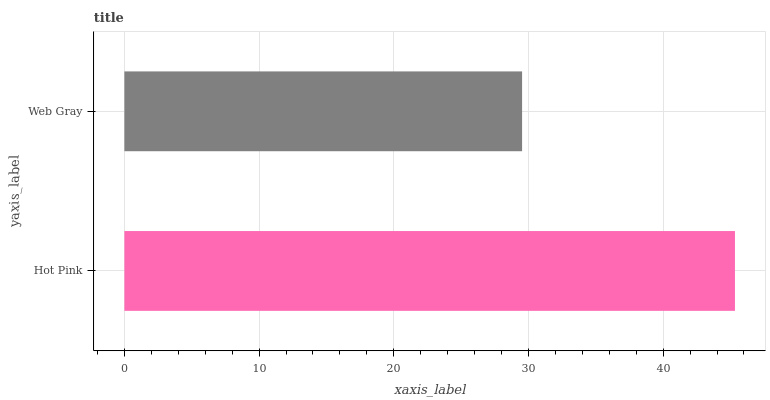Is Web Gray the minimum?
Answer yes or no. Yes. Is Hot Pink the maximum?
Answer yes or no. Yes. Is Web Gray the maximum?
Answer yes or no. No. Is Hot Pink greater than Web Gray?
Answer yes or no. Yes. Is Web Gray less than Hot Pink?
Answer yes or no. Yes. Is Web Gray greater than Hot Pink?
Answer yes or no. No. Is Hot Pink less than Web Gray?
Answer yes or no. No. Is Hot Pink the high median?
Answer yes or no. Yes. Is Web Gray the low median?
Answer yes or no. Yes. Is Web Gray the high median?
Answer yes or no. No. Is Hot Pink the low median?
Answer yes or no. No. 